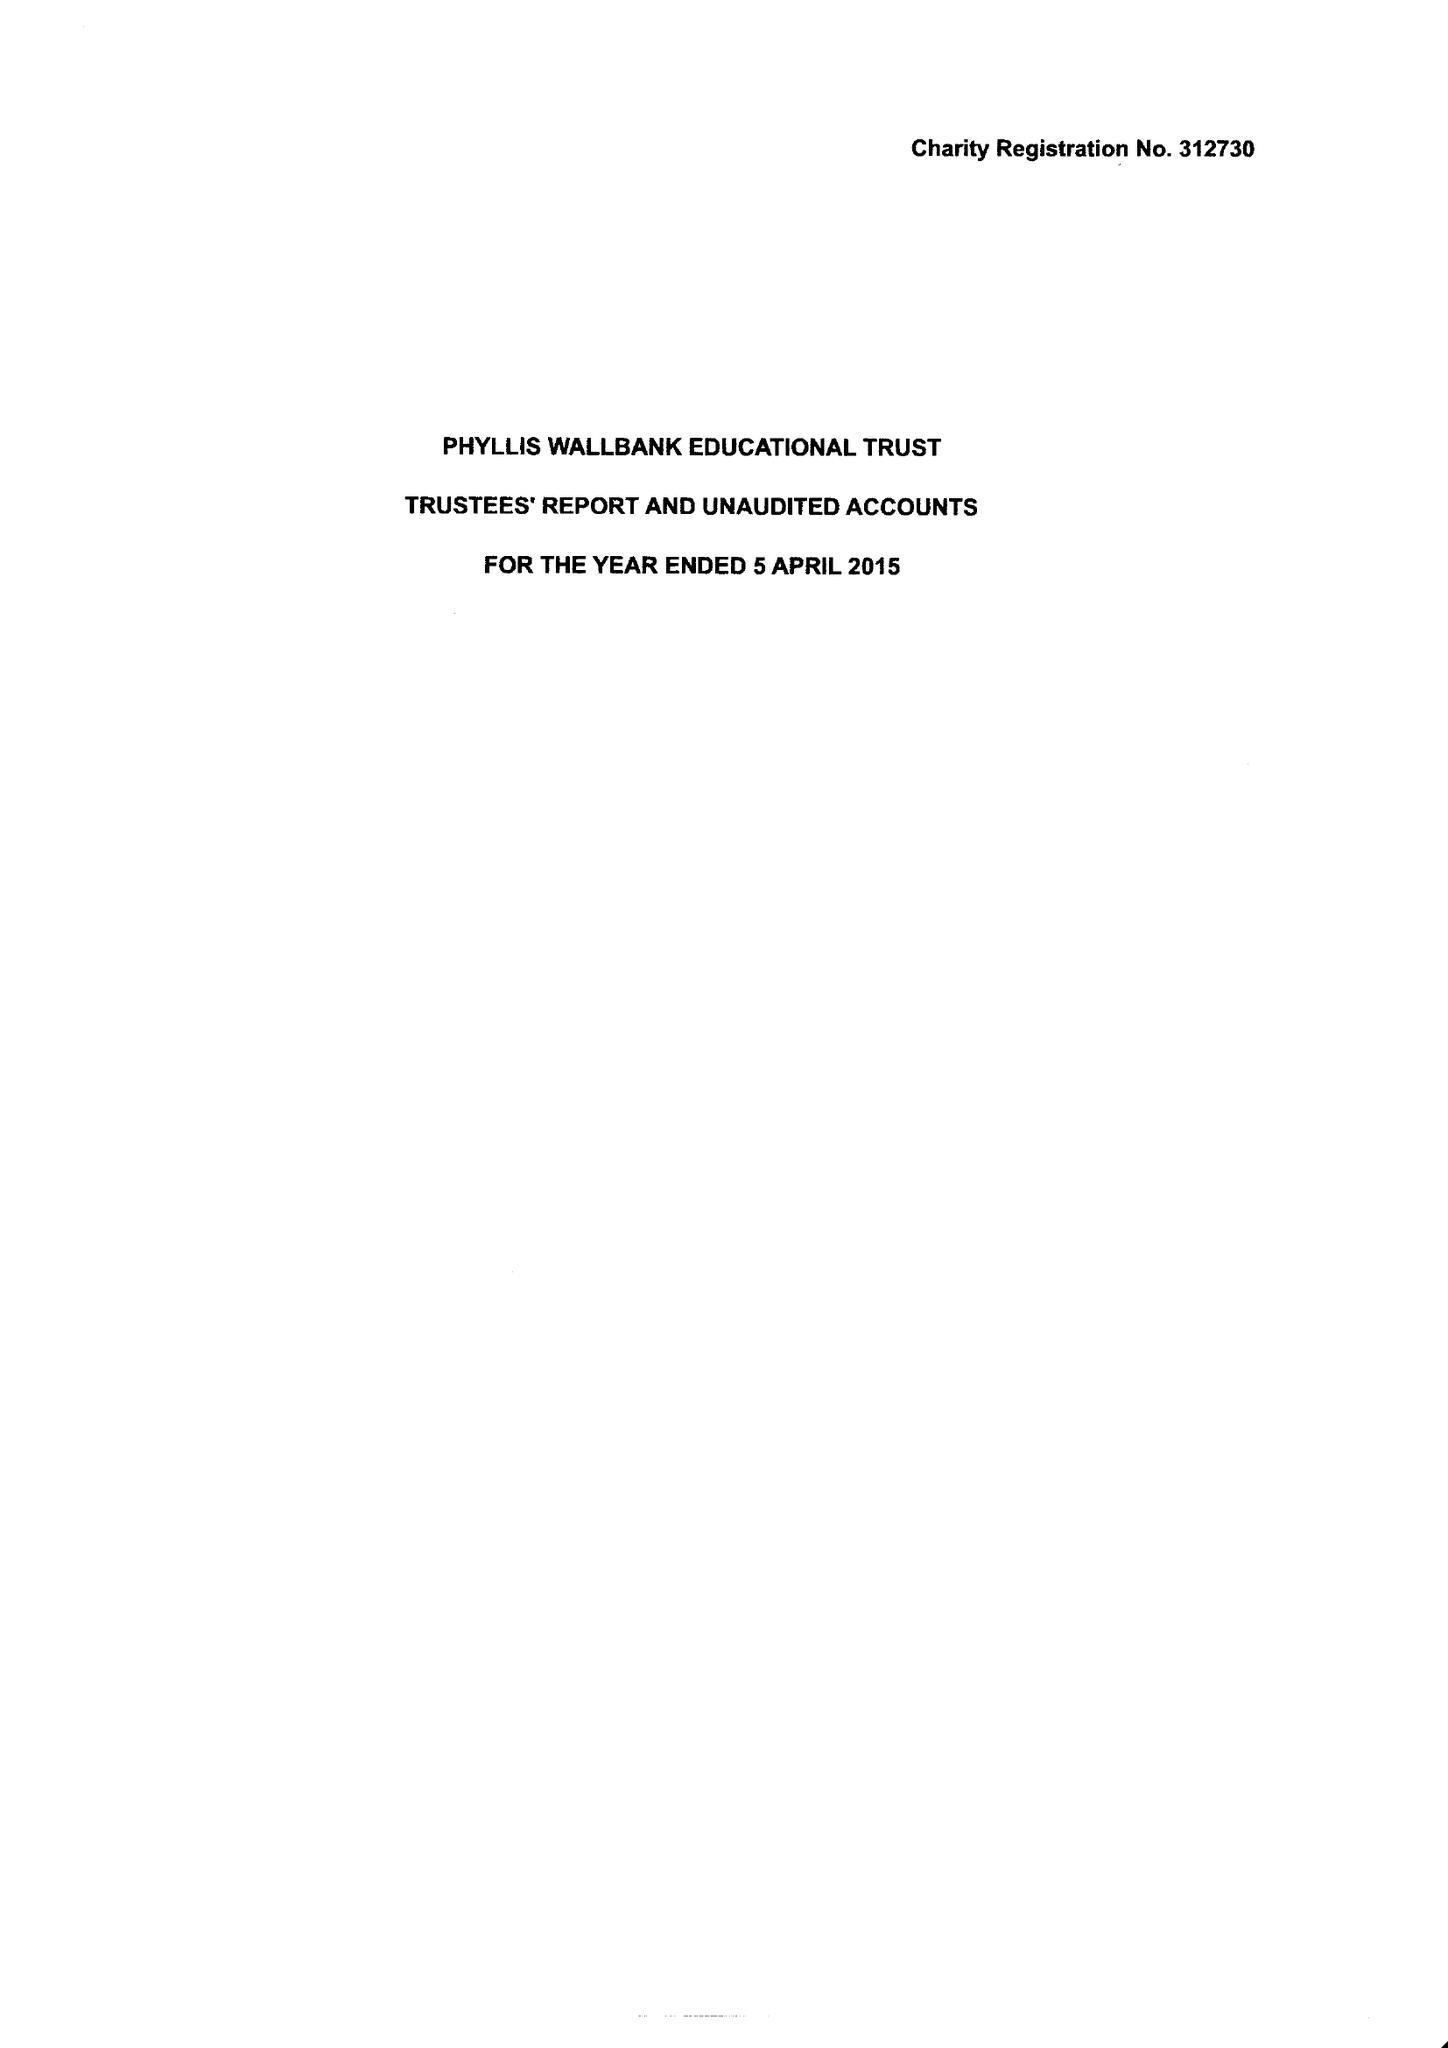What is the value for the spending_annually_in_british_pounds?
Answer the question using a single word or phrase. 60252.00 